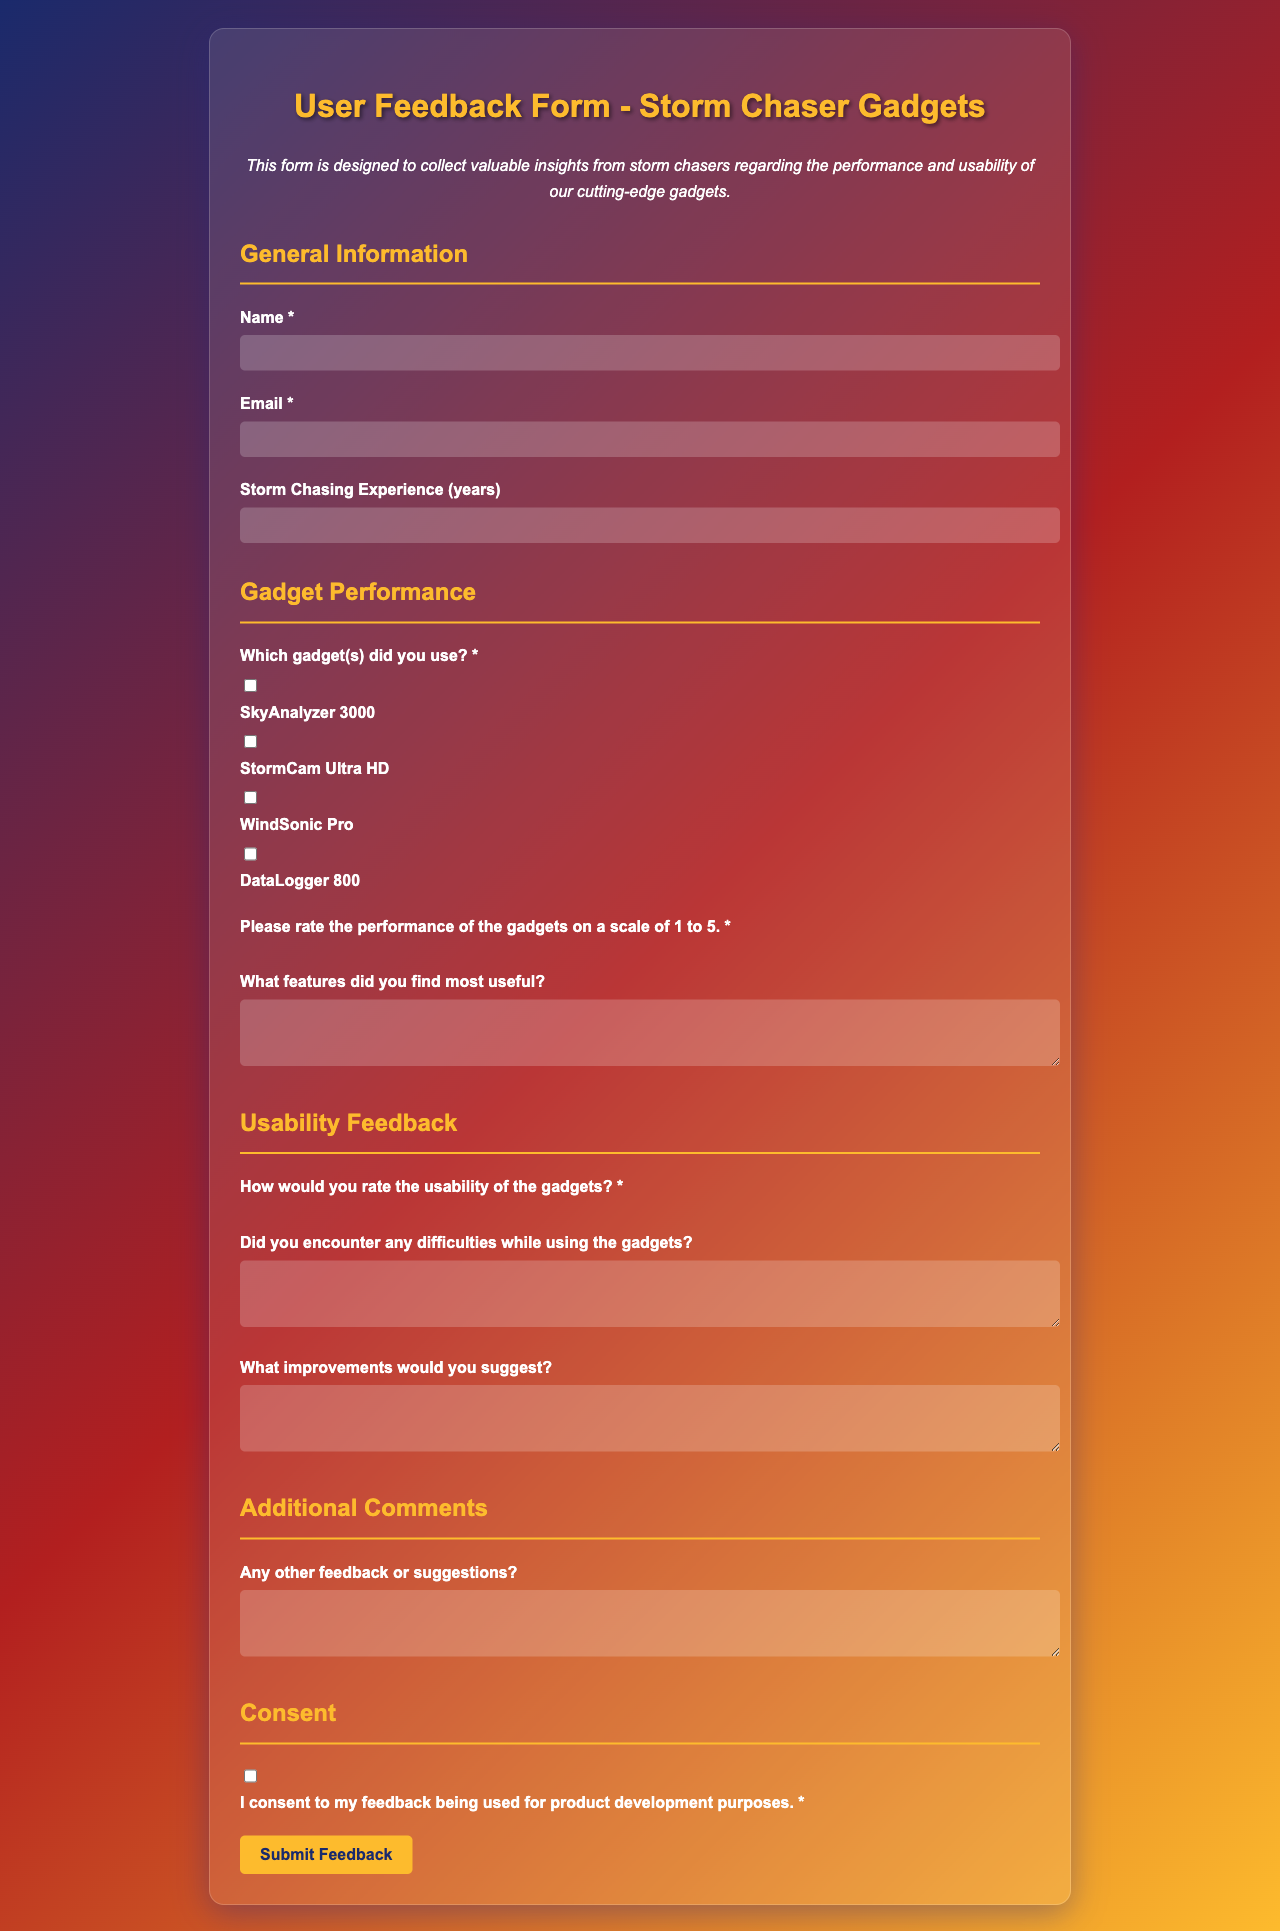what is the title of the form? The title of the form is presented at the top of the document, stating the purpose and focus of the feedback collection.
Answer: User Feedback Form - Storm Chaser Gadgets how many rating options are provided for gadget performance? The number of rating options can be counted in the gadget performance section, where a scale is given for ratings.
Answer: 5 what is the name of the first gadget listed? The first gadget is mentioned in a checkbox format, which can be identified easily.
Answer: SkyAnalyzer 3000 what is the required field for email? The form specifies which fields need to be filled out, indicated by an asterisk next to them.
Answer: Email what section follows Usability Feedback? The structure of the document carries distinct sections, helping to organize the feedback format clearly.
Answer: Additional Comments how many years of storm chasing experience are asked for in the form? The form asks for the experience duration in a numeric input indicating years, providing a clear solicitation for numerical responses.
Answer: None which feature allows users to confirm consent for feedback use? The document has a specific section where users need to acknowledge understanding and agreement, which is depicted with a checkbox.
Answer: I consent to my feedback being used for product development purposes what color is used for the title text? The document's styling defines the color for the title, which can be observed visually.
Answer: #fdbb2d what is the maximum width of the feedback form? The form's container has a set dimension outlined in the code, ensuring consistency in presentation.
Answer: 800px 